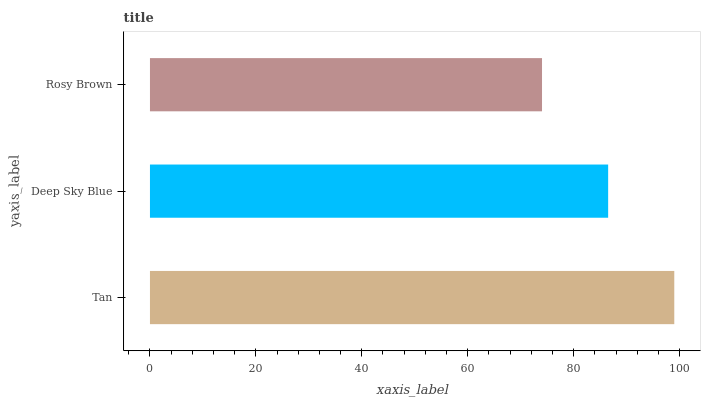Is Rosy Brown the minimum?
Answer yes or no. Yes. Is Tan the maximum?
Answer yes or no. Yes. Is Deep Sky Blue the minimum?
Answer yes or no. No. Is Deep Sky Blue the maximum?
Answer yes or no. No. Is Tan greater than Deep Sky Blue?
Answer yes or no. Yes. Is Deep Sky Blue less than Tan?
Answer yes or no. Yes. Is Deep Sky Blue greater than Tan?
Answer yes or no. No. Is Tan less than Deep Sky Blue?
Answer yes or no. No. Is Deep Sky Blue the high median?
Answer yes or no. Yes. Is Deep Sky Blue the low median?
Answer yes or no. Yes. Is Rosy Brown the high median?
Answer yes or no. No. Is Rosy Brown the low median?
Answer yes or no. No. 